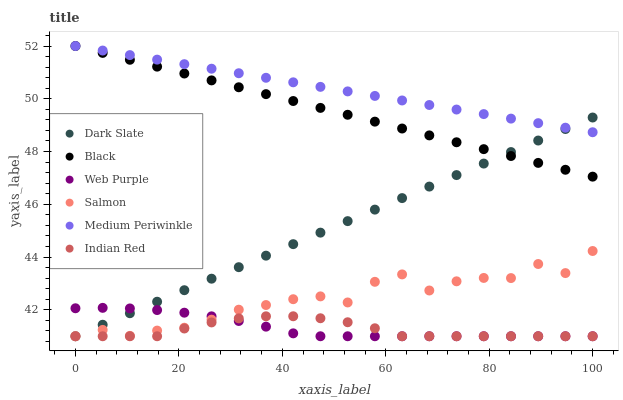Does Indian Red have the minimum area under the curve?
Answer yes or no. Yes. Does Medium Periwinkle have the maximum area under the curve?
Answer yes or no. Yes. Does Dark Slate have the minimum area under the curve?
Answer yes or no. No. Does Dark Slate have the maximum area under the curve?
Answer yes or no. No. Is Black the smoothest?
Answer yes or no. Yes. Is Salmon the roughest?
Answer yes or no. Yes. Is Medium Periwinkle the smoothest?
Answer yes or no. No. Is Medium Periwinkle the roughest?
Answer yes or no. No. Does Salmon have the lowest value?
Answer yes or no. Yes. Does Medium Periwinkle have the lowest value?
Answer yes or no. No. Does Black have the highest value?
Answer yes or no. Yes. Does Dark Slate have the highest value?
Answer yes or no. No. Is Indian Red less than Black?
Answer yes or no. Yes. Is Black greater than Salmon?
Answer yes or no. Yes. Does Indian Red intersect Dark Slate?
Answer yes or no. Yes. Is Indian Red less than Dark Slate?
Answer yes or no. No. Is Indian Red greater than Dark Slate?
Answer yes or no. No. Does Indian Red intersect Black?
Answer yes or no. No. 